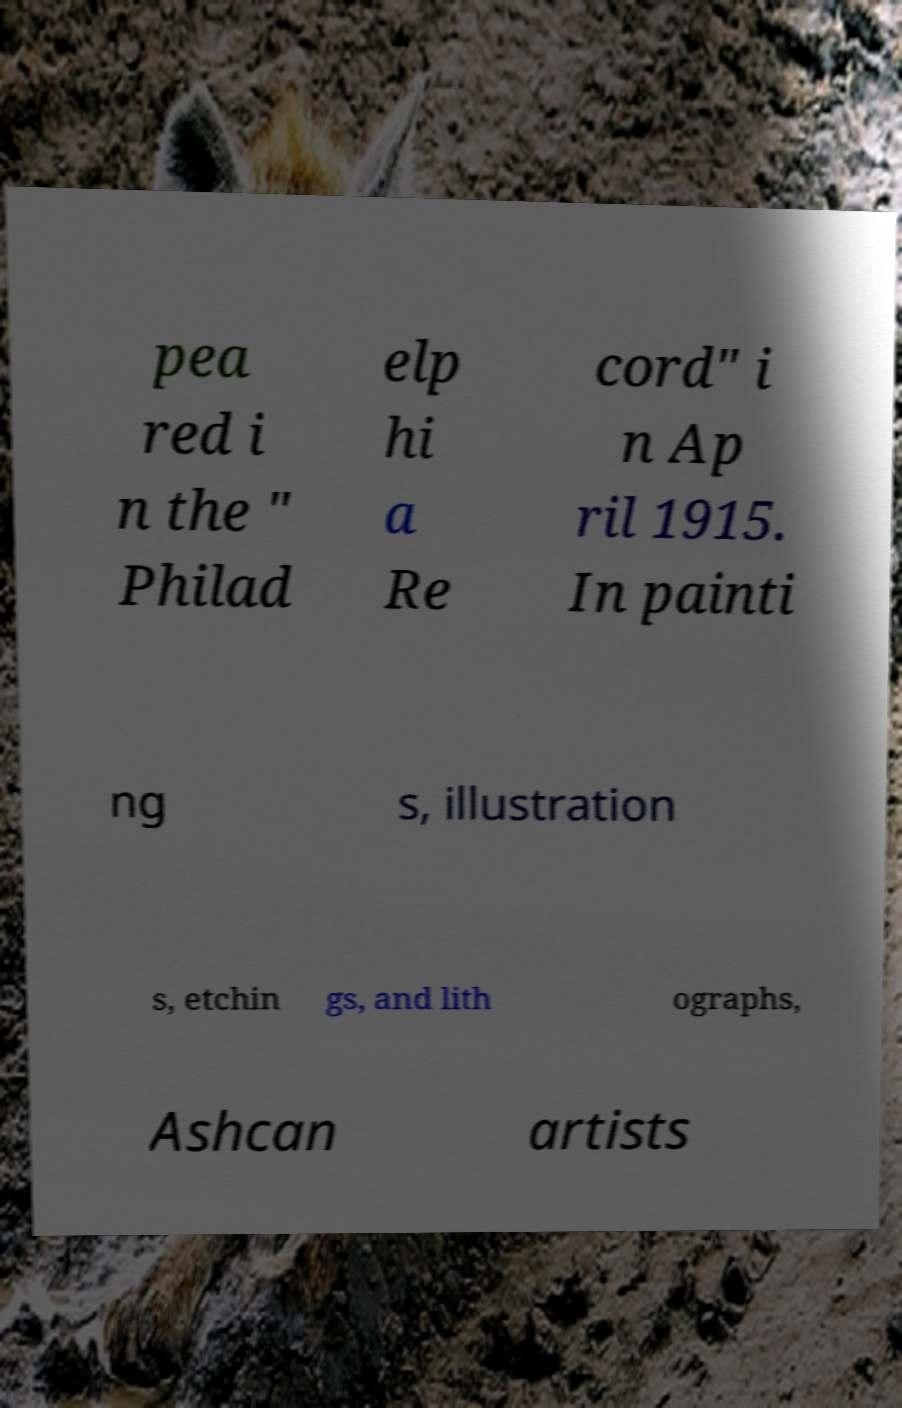Could you assist in decoding the text presented in this image and type it out clearly? pea red i n the " Philad elp hi a Re cord" i n Ap ril 1915. In painti ng s, illustration s, etchin gs, and lith ographs, Ashcan artists 